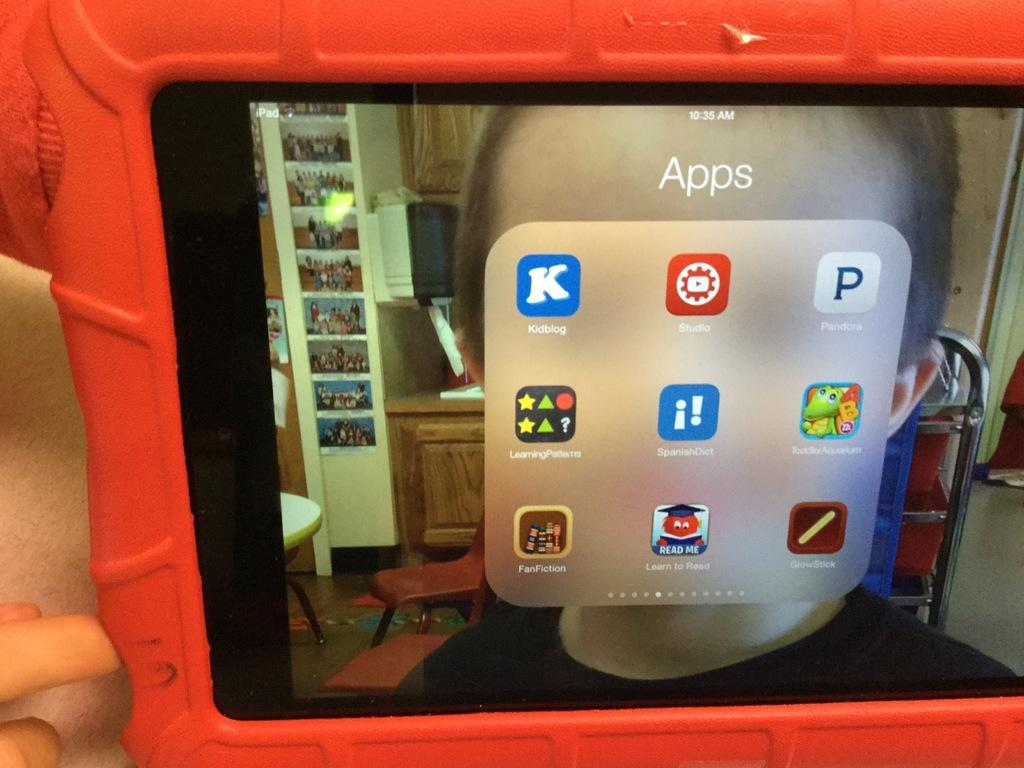<image>
Write a terse but informative summary of the picture. IPad screen that has the word "Apps" on there. 